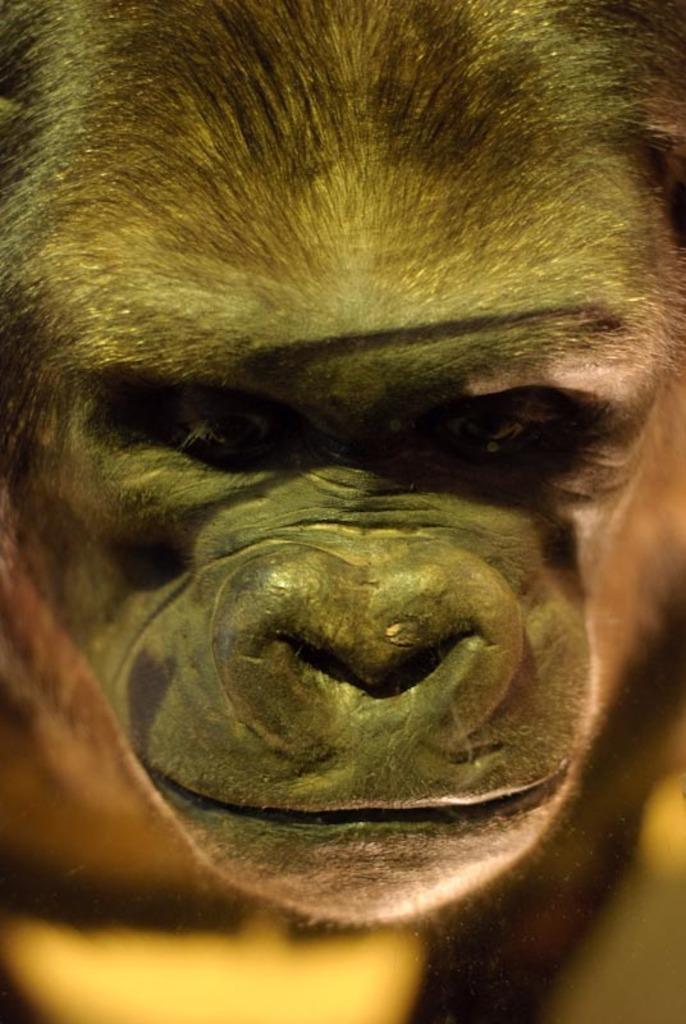Could you give a brief overview of what you see in this image? In this picture I can see there is a monkey and it has a mouth, eye and hair on its body. 